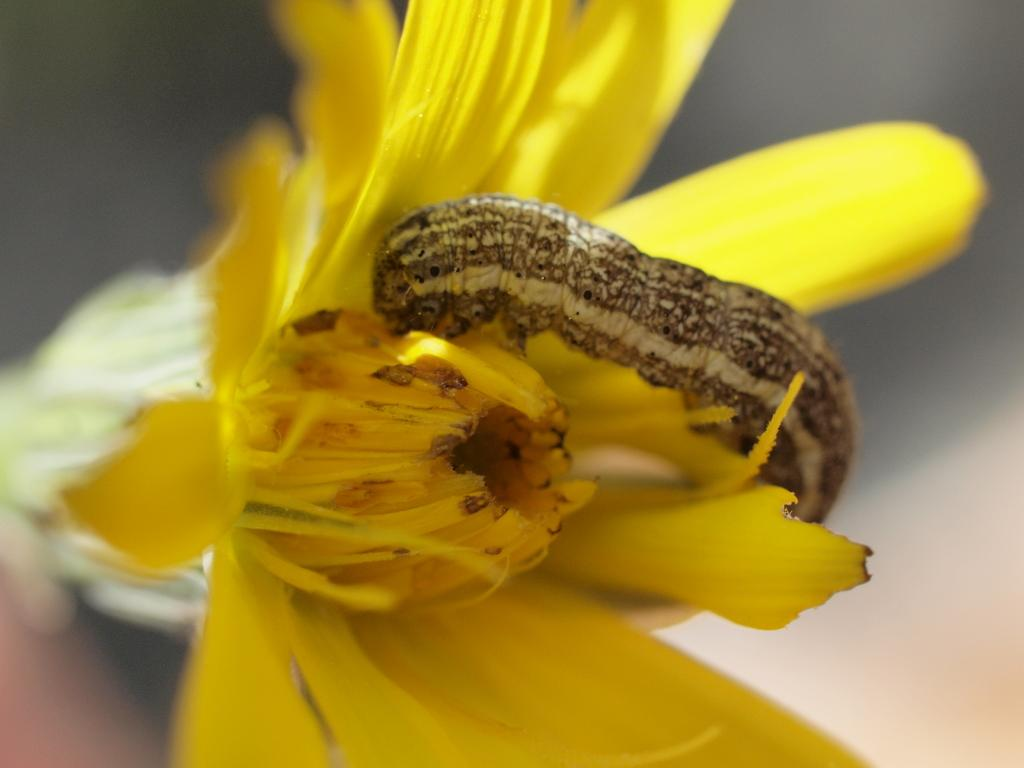What type of flower can be seen in the image? There is a yellow color flower in the image. Is there any other living organism on the flower? Yes, a caterpillar is present on the flower. What are the main features of the flower? The flower has petals and pollen grains. How would you describe the background of the image? The background of the image is blurry. What company does the stranger in the image work for? There is no stranger present in the image, so it is not possible to determine which company they might work for. 